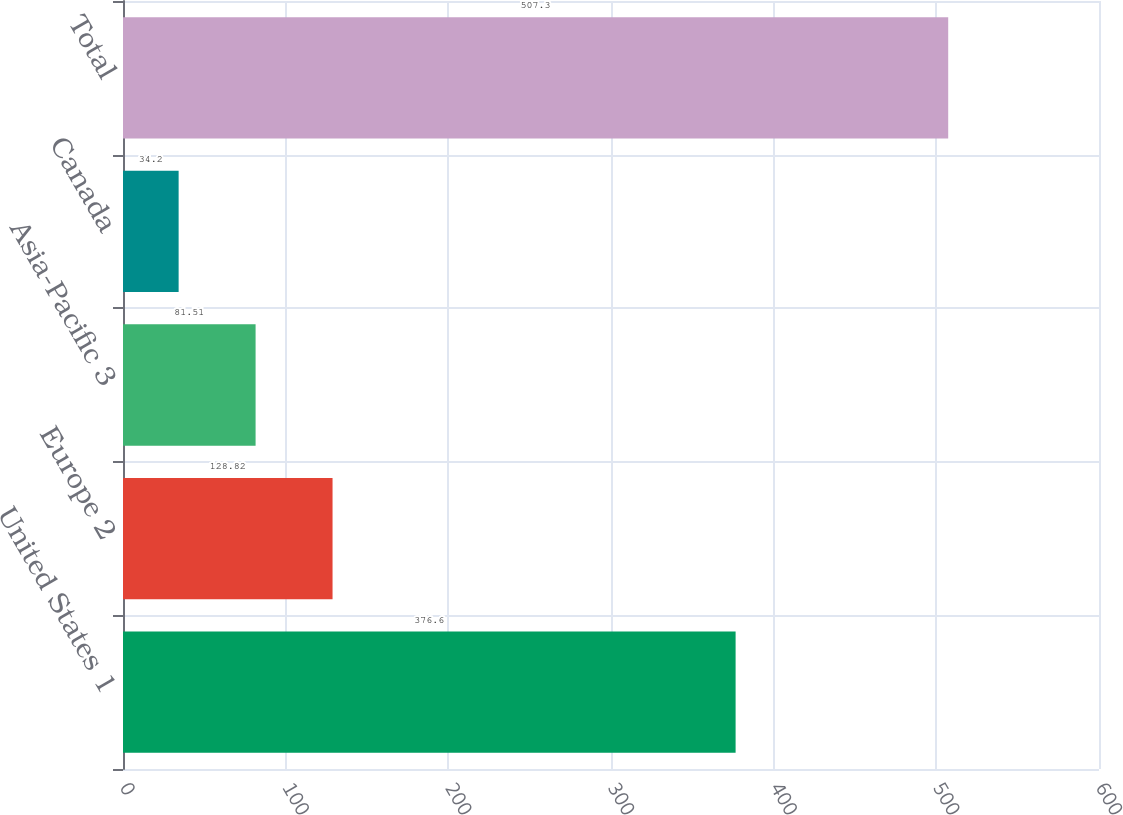Convert chart to OTSL. <chart><loc_0><loc_0><loc_500><loc_500><bar_chart><fcel>United States 1<fcel>Europe 2<fcel>Asia-Pacific 3<fcel>Canada<fcel>Total<nl><fcel>376.6<fcel>128.82<fcel>81.51<fcel>34.2<fcel>507.3<nl></chart> 